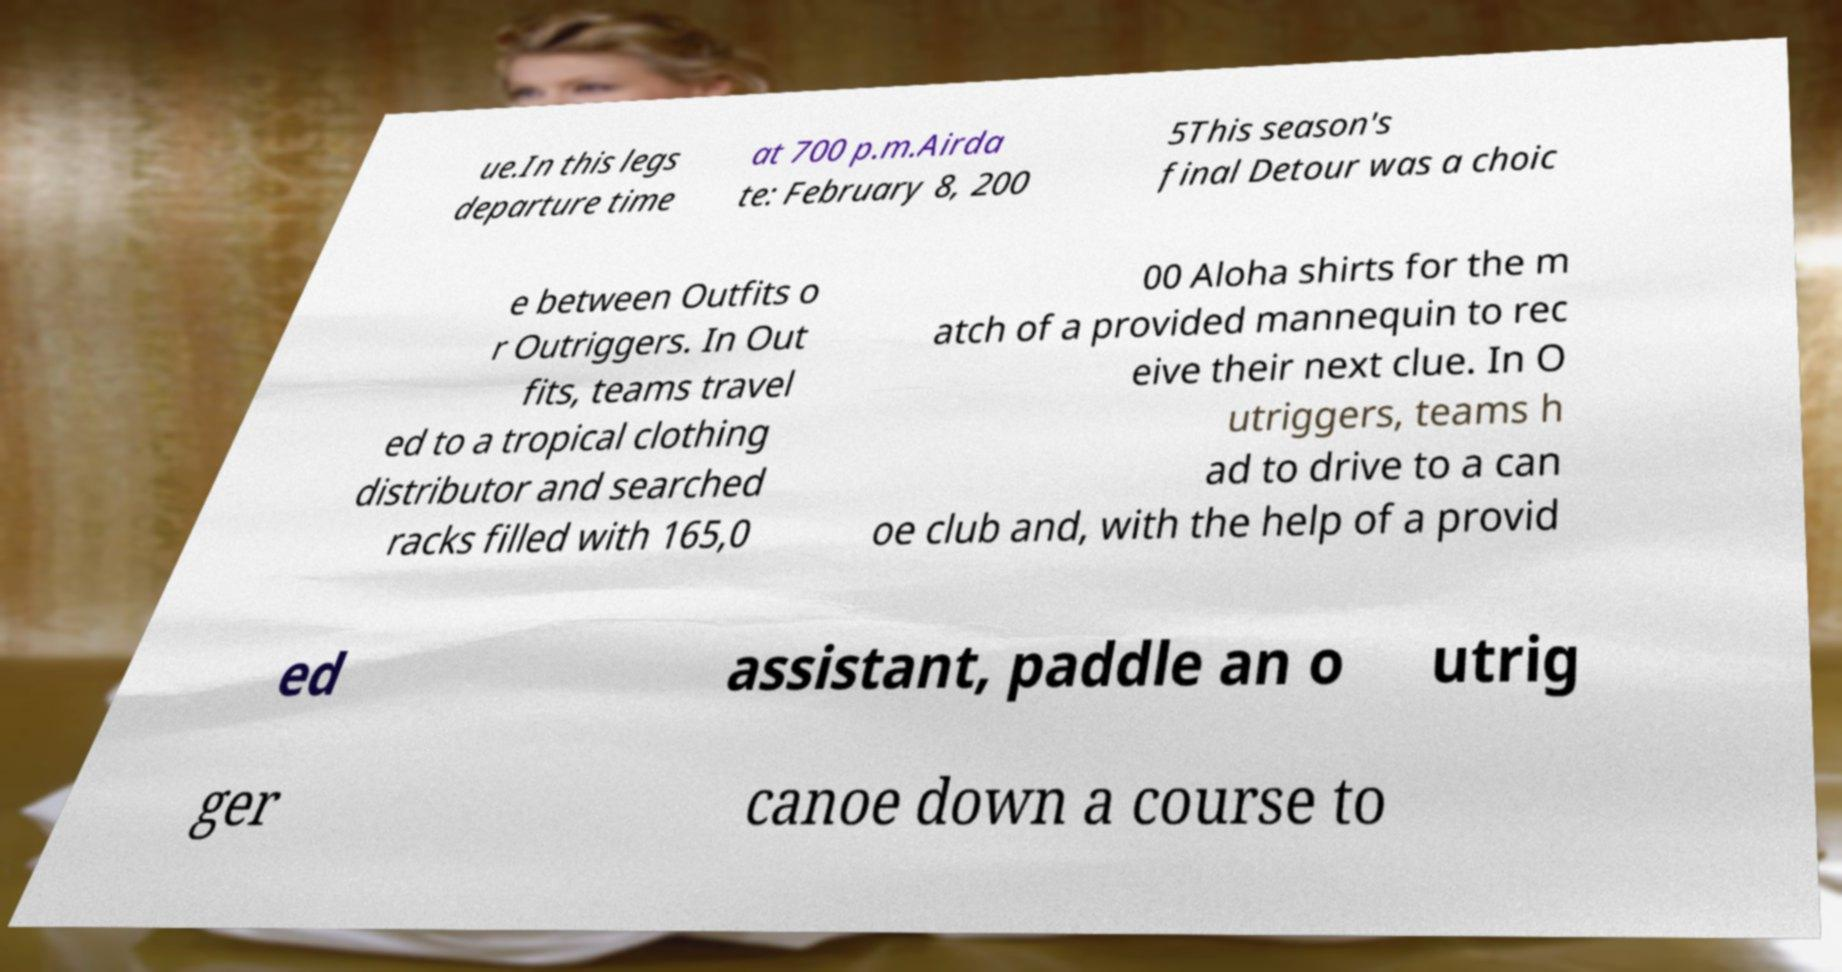Can you read and provide the text displayed in the image?This photo seems to have some interesting text. Can you extract and type it out for me? ue.In this legs departure time at 700 p.m.Airda te: February 8, 200 5This season's final Detour was a choic e between Outfits o r Outriggers. In Out fits, teams travel ed to a tropical clothing distributor and searched racks filled with 165,0 00 Aloha shirts for the m atch of a provided mannequin to rec eive their next clue. In O utriggers, teams h ad to drive to a can oe club and, with the help of a provid ed assistant, paddle an o utrig ger canoe down a course to 